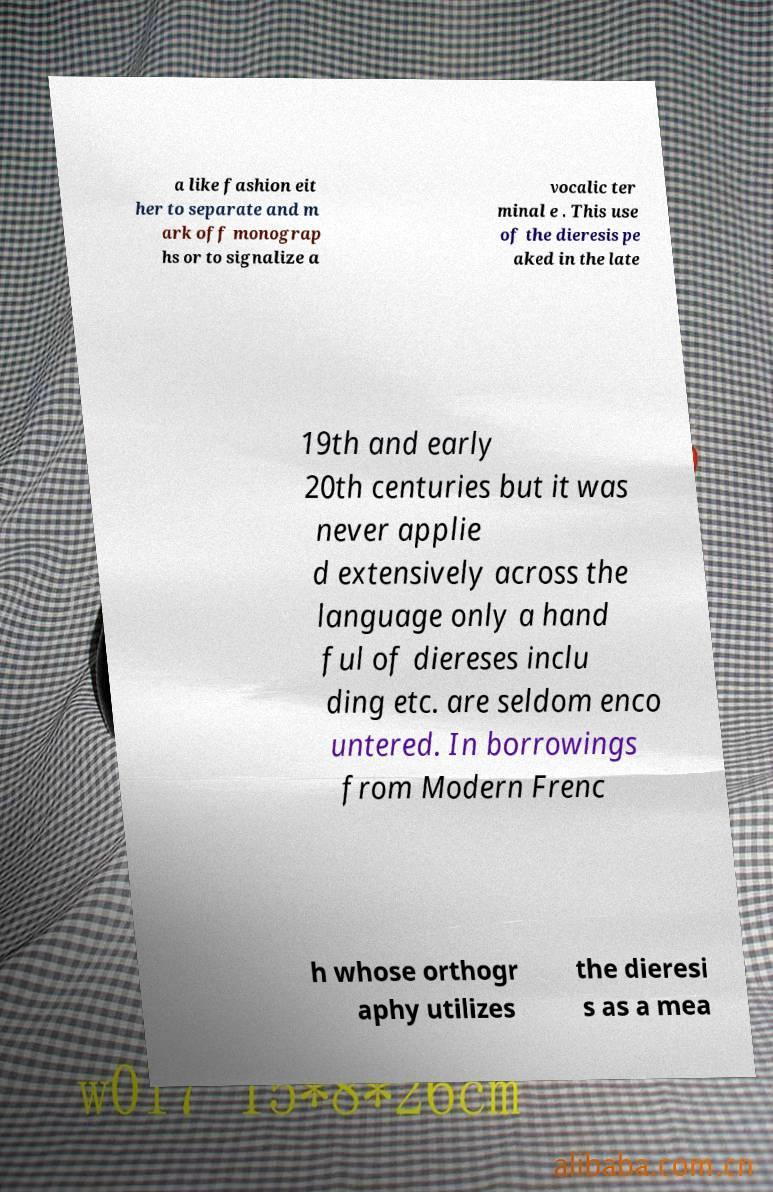Can you read and provide the text displayed in the image?This photo seems to have some interesting text. Can you extract and type it out for me? a like fashion eit her to separate and m ark off monograp hs or to signalize a vocalic ter minal e . This use of the dieresis pe aked in the late 19th and early 20th centuries but it was never applie d extensively across the language only a hand ful of diereses inclu ding etc. are seldom enco untered. In borrowings from Modern Frenc h whose orthogr aphy utilizes the dieresi s as a mea 